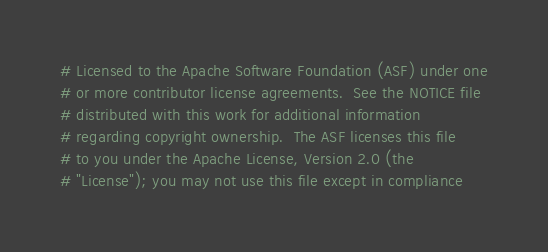<code> <loc_0><loc_0><loc_500><loc_500><_Python_># Licensed to the Apache Software Foundation (ASF) under one
# or more contributor license agreements.  See the NOTICE file
# distributed with this work for additional information
# regarding copyright ownership.  The ASF licenses this file
# to you under the Apache License, Version 2.0 (the
# "License"); you may not use this file except in compliance</code> 